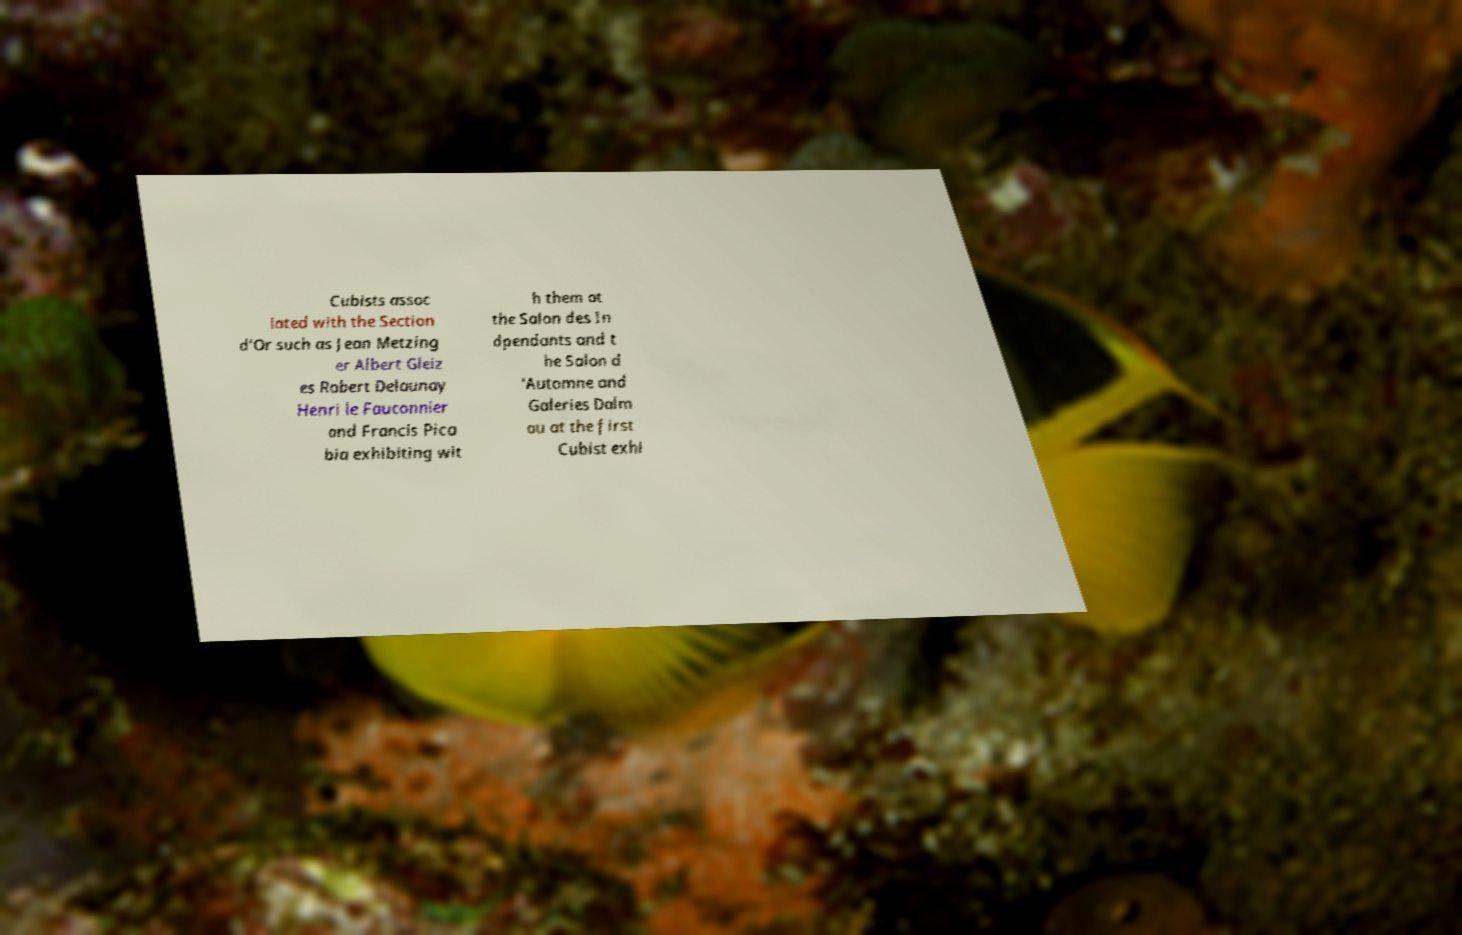Could you assist in decoding the text presented in this image and type it out clearly? Cubists assoc iated with the Section d'Or such as Jean Metzing er Albert Gleiz es Robert Delaunay Henri le Fauconnier and Francis Pica bia exhibiting wit h them at the Salon des In dpendants and t he Salon d 'Automne and Galeries Dalm au at the first Cubist exhi 